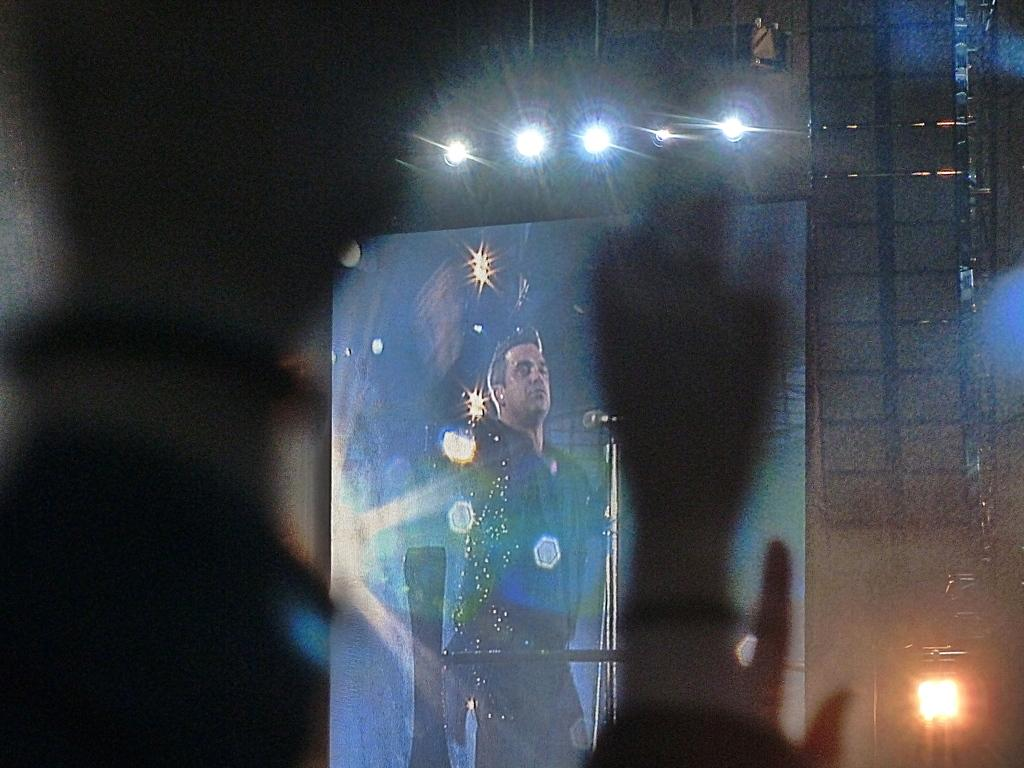What is the main object in the image? There is a board in the image. Is there anyone on the board? Yes, there is a person on the board. What else can be seen in the image? There are lights visible in the image. Can you see any bees buzzing around the person on the board? There are no bees visible in the image. What type of soap is being used by the person on the board? There is no soap present in the image. 